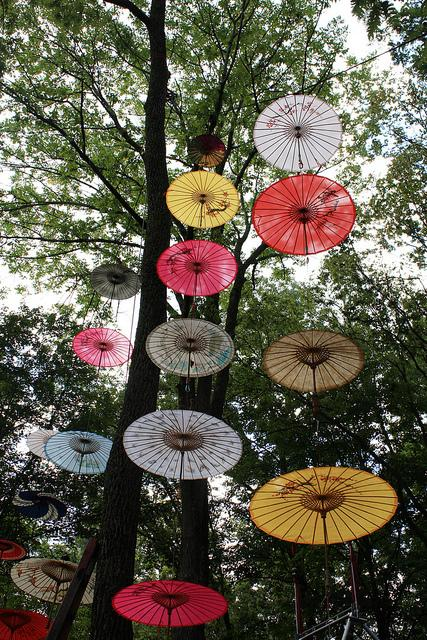What is near the colorful items?

Choices:
A) tree
B) tiger
C) onion
D) beach house tree 